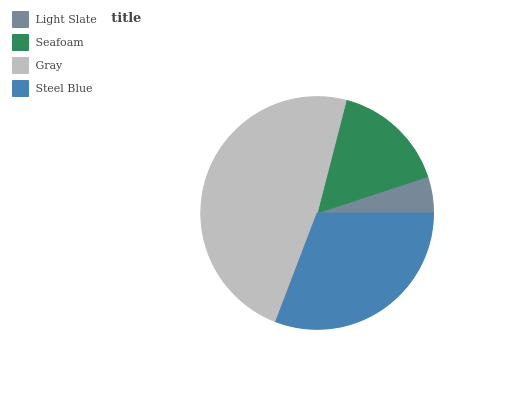Is Light Slate the minimum?
Answer yes or no. Yes. Is Gray the maximum?
Answer yes or no. Yes. Is Seafoam the minimum?
Answer yes or no. No. Is Seafoam the maximum?
Answer yes or no. No. Is Seafoam greater than Light Slate?
Answer yes or no. Yes. Is Light Slate less than Seafoam?
Answer yes or no. Yes. Is Light Slate greater than Seafoam?
Answer yes or no. No. Is Seafoam less than Light Slate?
Answer yes or no. No. Is Steel Blue the high median?
Answer yes or no. Yes. Is Seafoam the low median?
Answer yes or no. Yes. Is Light Slate the high median?
Answer yes or no. No. Is Steel Blue the low median?
Answer yes or no. No. 